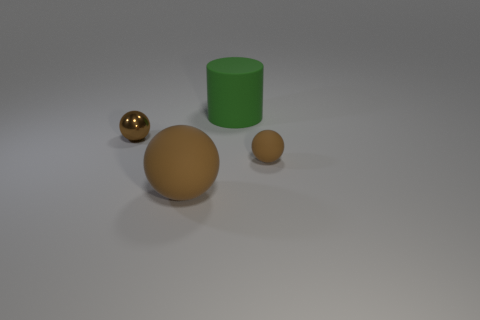Is there any other thing that has the same color as the large sphere?
Keep it short and to the point. Yes. There is a tiny rubber thing; does it have the same color as the sphere that is on the left side of the large brown rubber object?
Your answer should be very brief. Yes. What shape is the small object that is in front of the sphere that is behind the tiny brown matte object?
Keep it short and to the point. Sphere. What size is the matte object that is the same color as the big sphere?
Your answer should be very brief. Small. Do the large object left of the green matte thing and the tiny shiny thing have the same shape?
Offer a terse response. Yes. Is the number of matte objects in front of the large green matte cylinder greater than the number of metallic objects on the right side of the large brown thing?
Your answer should be very brief. Yes. How many rubber balls are right of the big matte thing that is behind the small metal ball?
Make the answer very short. 1. There is a large thing that is the same color as the small rubber ball; what material is it?
Keep it short and to the point. Rubber. What number of other things are the same color as the tiny metal object?
Provide a succinct answer. 2. There is a object that is behind the brown shiny thing in front of the big green cylinder; what is its color?
Offer a terse response. Green. 